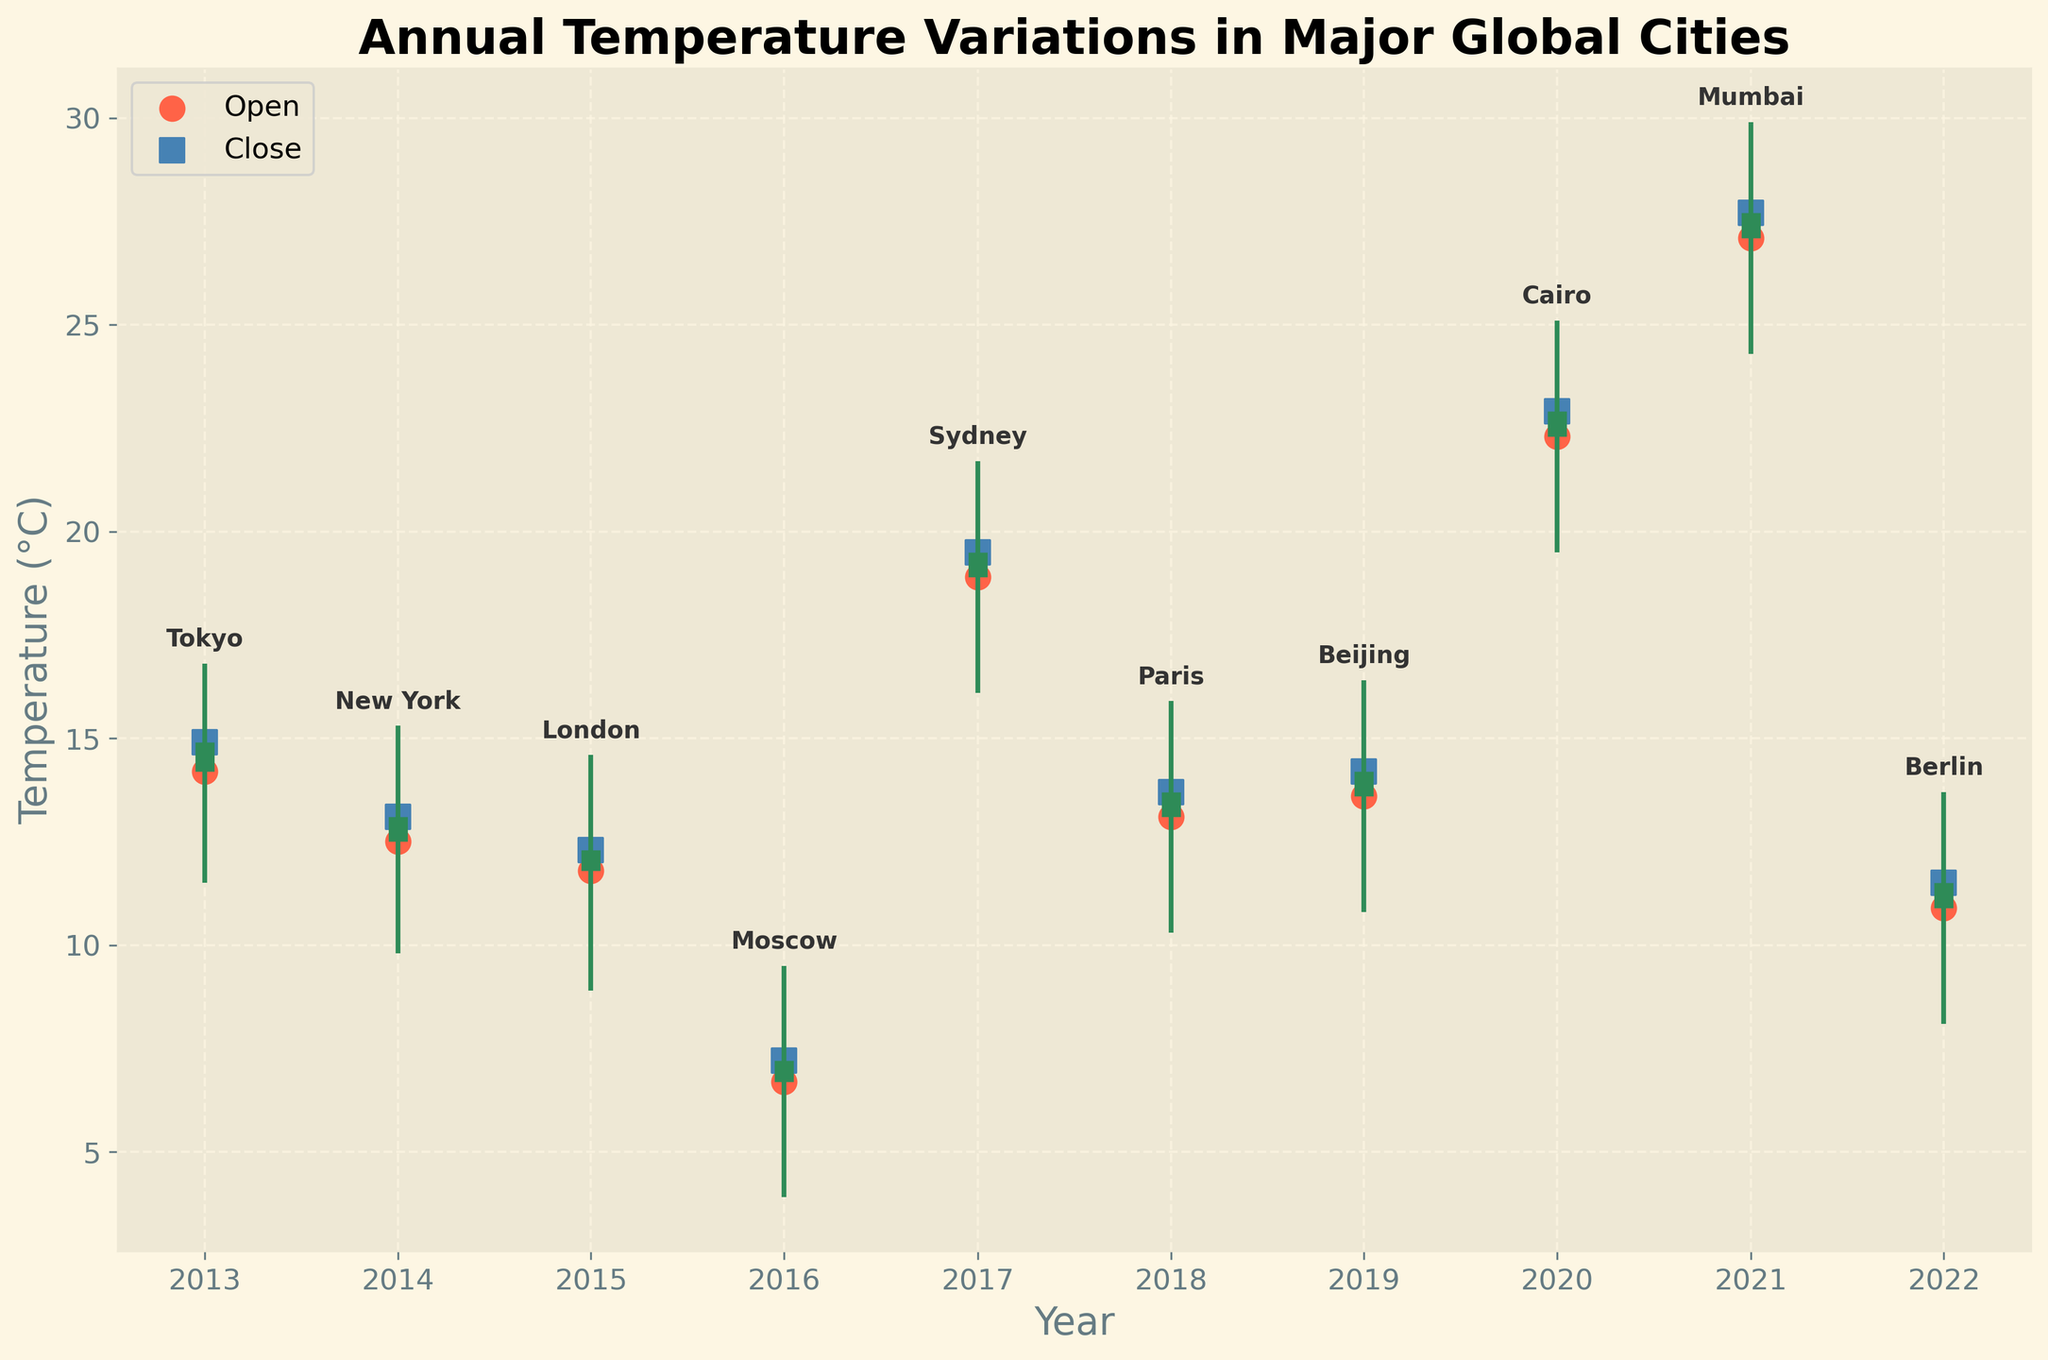what is the highest temperature recorded in Tokyo? The highest temperature recorded in Tokyo is represented by the top of the vertical line corresponding to Tokyo in the year 2013. This line shows a maximum temperature of 16.8°C.
Answer: 16.8°C what year does Cairo have an average temperature of 25.1°C? The chart shows Cairo's data in 2020, and the highest point on the vertical line corresponding to Cairo displays 25.1°C.
Answer: 2020 How does the open temperature of New York in 2014 compare to its close temperature? The open and close temperatures of New York for the year 2014 are represented by a red circle and a blue square, respectively. The open temperature is 12.5°C, and the close temperature is 13.1°C, indicating an increase.
Answer: The close temperature is higher Which city had the highest open temperature over the decade? By comparing all the red circles (open temperatures), the highest open temperature is found in Mumbai in 2021 with 27.1°C.
Answer: Mumbai Are there any cities where the closing temperature is lower than the opening temperature? By examining the red circles (open) and blue squares (close), Tokyo in 2013 is one example where the closing temperature (14.9°C) is higher than the opening temperature (14.2°C).
Answer: Yes, Tokyo in 2013 Calculate the average high temperature for the cities listed. The high temperatures are: 16.8, 15.3, 14.6, 9.5, 21.7, 15.9, 16.4, 25.1, 29.9, 13.7. Summing these gives a total of 179.9, and there are 10 cities. So, the average is 179.9 / 10 = 17.99°C.
Answer: 17.99°C Is there any year with a closing temperature lower than 10°C? Reviewing the blue squares (closing temperatures), no city's closing temperature falls below 10°C in any year recorded.
Answer: No How does the average annual temperature (open temperature) in Berlin compare to that of Moscow? The open temperature for Berlin in 2022 is 10.9°C, and Moscow in 2016 is 6.7°C. The difference is 10.9°C - 6.7°C = 4.2°C
Answer: Berlin's average annual temperature is 4.2°C higher In which year did Tokyo have its highest temperature? From Tokyo’s data in 2013, the highest temperature in Tokyo is 16.8°C, recorded in the year 2013.
Answer: 2013 